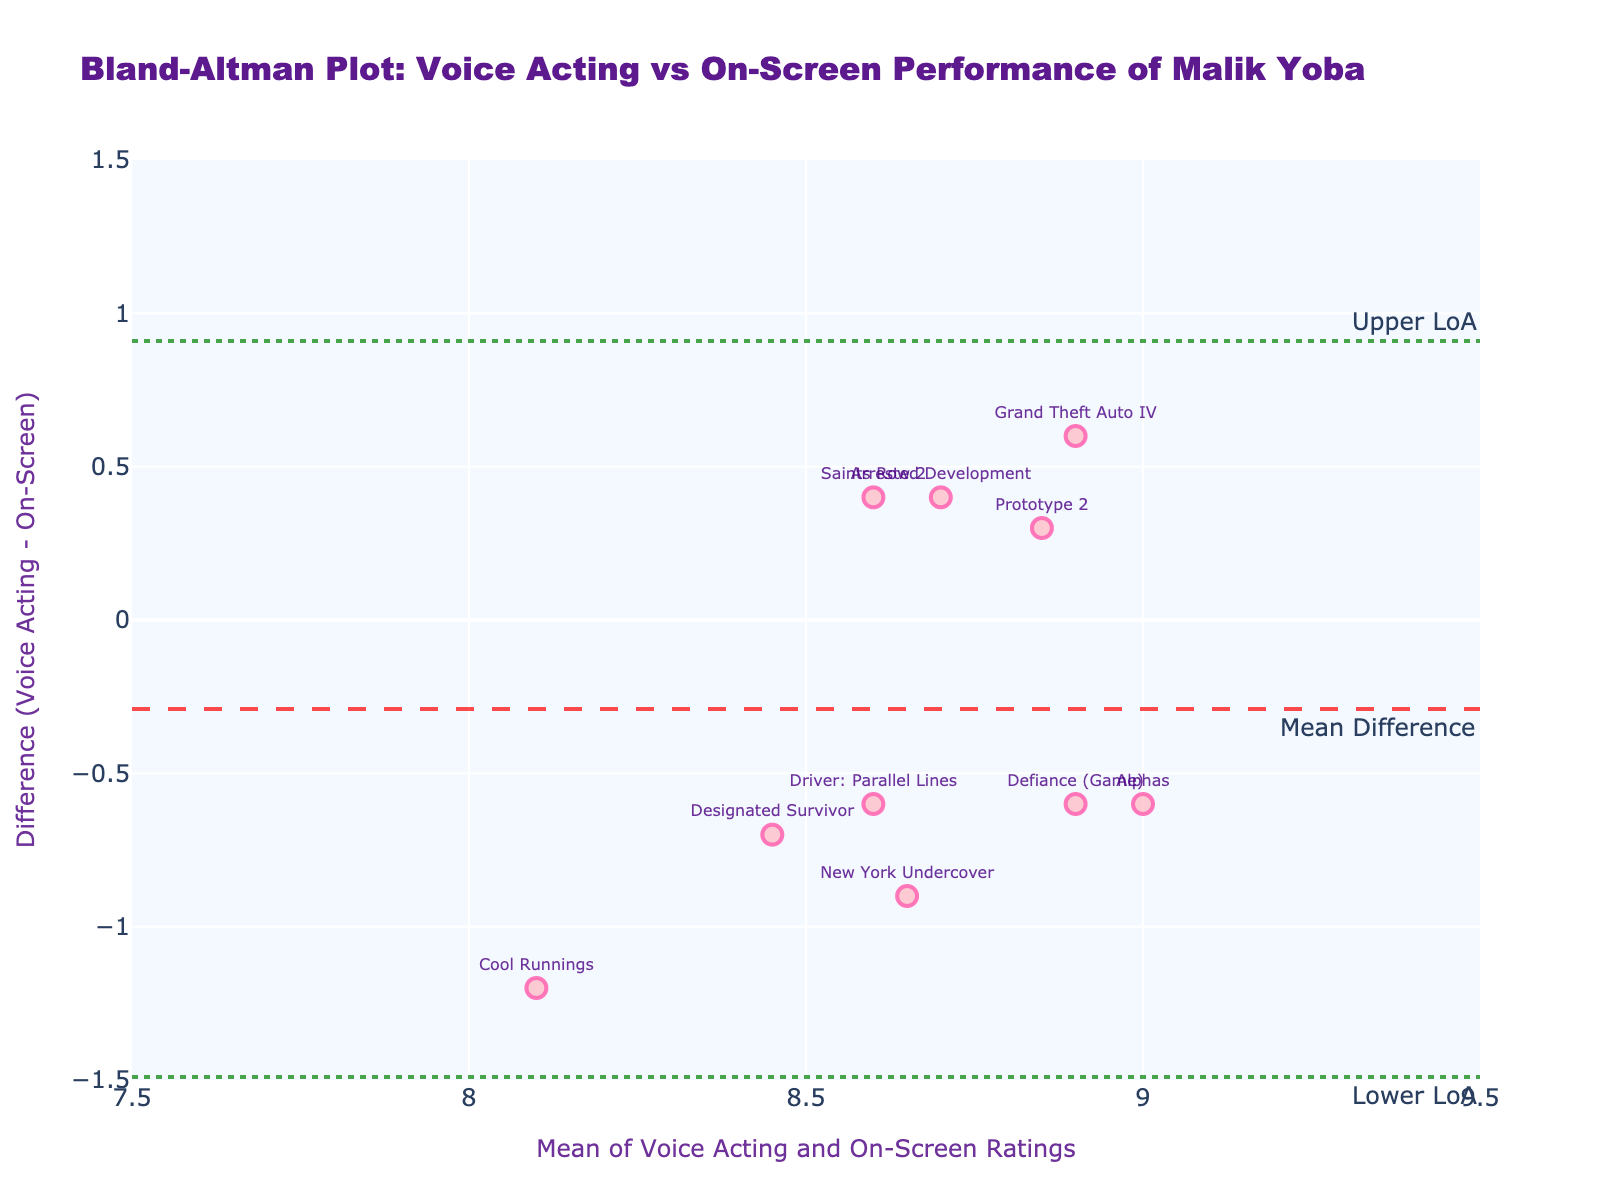what is the title of the figure? The title of a figure is usually placed at the top of the plot. In this case, it reads "Bland-Altman Plot: Voice Acting vs On-Screen Performance of Malik Yoba."
Answer: Bland-Altman Plot: Voice Acting vs On-Screen Performance of Malik Yoba How many data points are plotted in the figure? Each data point in the scatter plot represents a performance type by Malik Yoba. By counting the markers, we see there are 10 points plotted.
Answer: 10 What do the x-axis and y-axis represent in this plot? The x-axis title indicates it represents the "Mean of Voice Acting and On-Screen Ratings", while the y-axis title indicates it represents the "Difference (Voice Acting - On-Screen)."
Answer: x-axis: Mean of Voice Acting and On-Screen Ratings; y-axis: Difference (Voice Acting - On-Screen) What is the mean difference of the ratings? The mean difference is indicated by the horizontal dashed line that is annotated with "Mean Difference". This line intersects the y-axis at 0.08.
Answer: 0.08 What performance type has the largest positive difference? By identifying the data point with the highest y-value (difference), we see that "Grand Theft Auto IV" has the largest positive difference.
Answer: Grand Theft Auto IV What are the upper and lower lines of agreement (LoA)? The upper LoA and lower LoA are marked by horizontal dotted lines on the plot. According to their captions, the upper LoA is approximately 0.92 and the lower LoA is approximately -0.76.
Answer: Upper LoA: 0.92; Lower LoA: -0.76 How does the difference for "Designated Survivor" compare to the mean difference? We locate the point for "Designated Survivor" on the y-axis, which appears to be slightly below the mean difference line of 0.08.
Answer: Slightly below Which performance type has a difference closest to zero? The point that is closest to the y-axis (0) represents "Arrested Development".
Answer: Arrested Development What is the average y-value (difference) of the three video games: "Grand Theft Auto IV", "Saints Row 2", and "Prototype 2"? First, identify the y-values (differences) for these points: "Grand Theft Auto IV" is 0.6, "Saints Row 2" is 0.4, and "Prototype 2" is 0.3. The average is calculated as (0.6 + 0.4 + 0.3) / 3 = 0.43.
Answer: 0.43 Which performance type has a mean rating closest to 8.6? By finding the mean values and closest to 8.6, we see "Prototype 2" has a mean very close to this value.
Answer: Prototype 2 